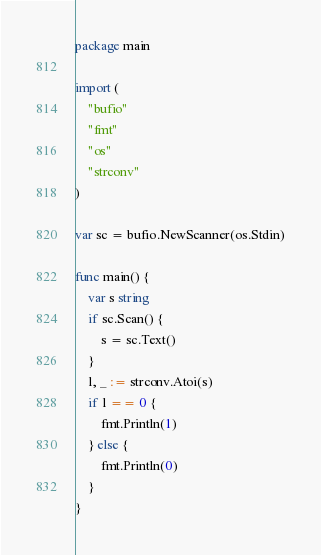<code> <loc_0><loc_0><loc_500><loc_500><_Go_>package main

import (
	"bufio"
	"fmt"
	"os"
	"strconv"
)

var sc = bufio.NewScanner(os.Stdin)

func main() {
	var s string
	if sc.Scan() {
		s = sc.Text()
	}
	l, _ := strconv.Atoi(s)
	if l == 0 {
		fmt.Println(1)
	} else {
		fmt.Println(0)
	}
}
</code> 